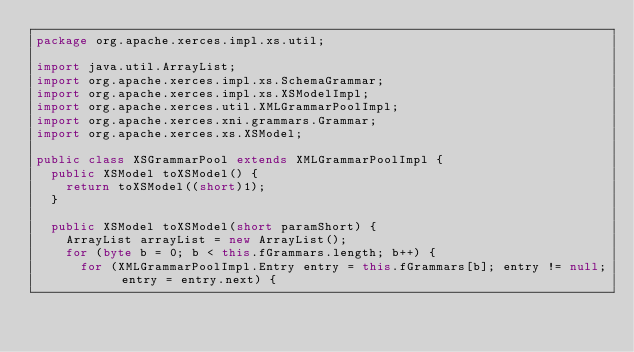Convert code to text. <code><loc_0><loc_0><loc_500><loc_500><_Java_>package org.apache.xerces.impl.xs.util;

import java.util.ArrayList;
import org.apache.xerces.impl.xs.SchemaGrammar;
import org.apache.xerces.impl.xs.XSModelImpl;
import org.apache.xerces.util.XMLGrammarPoolImpl;
import org.apache.xerces.xni.grammars.Grammar;
import org.apache.xerces.xs.XSModel;

public class XSGrammarPool extends XMLGrammarPoolImpl {
  public XSModel toXSModel() {
    return toXSModel((short)1);
  }
  
  public XSModel toXSModel(short paramShort) {
    ArrayList arrayList = new ArrayList();
    for (byte b = 0; b < this.fGrammars.length; b++) {
      for (XMLGrammarPoolImpl.Entry entry = this.fGrammars[b]; entry != null; entry = entry.next) {</code> 